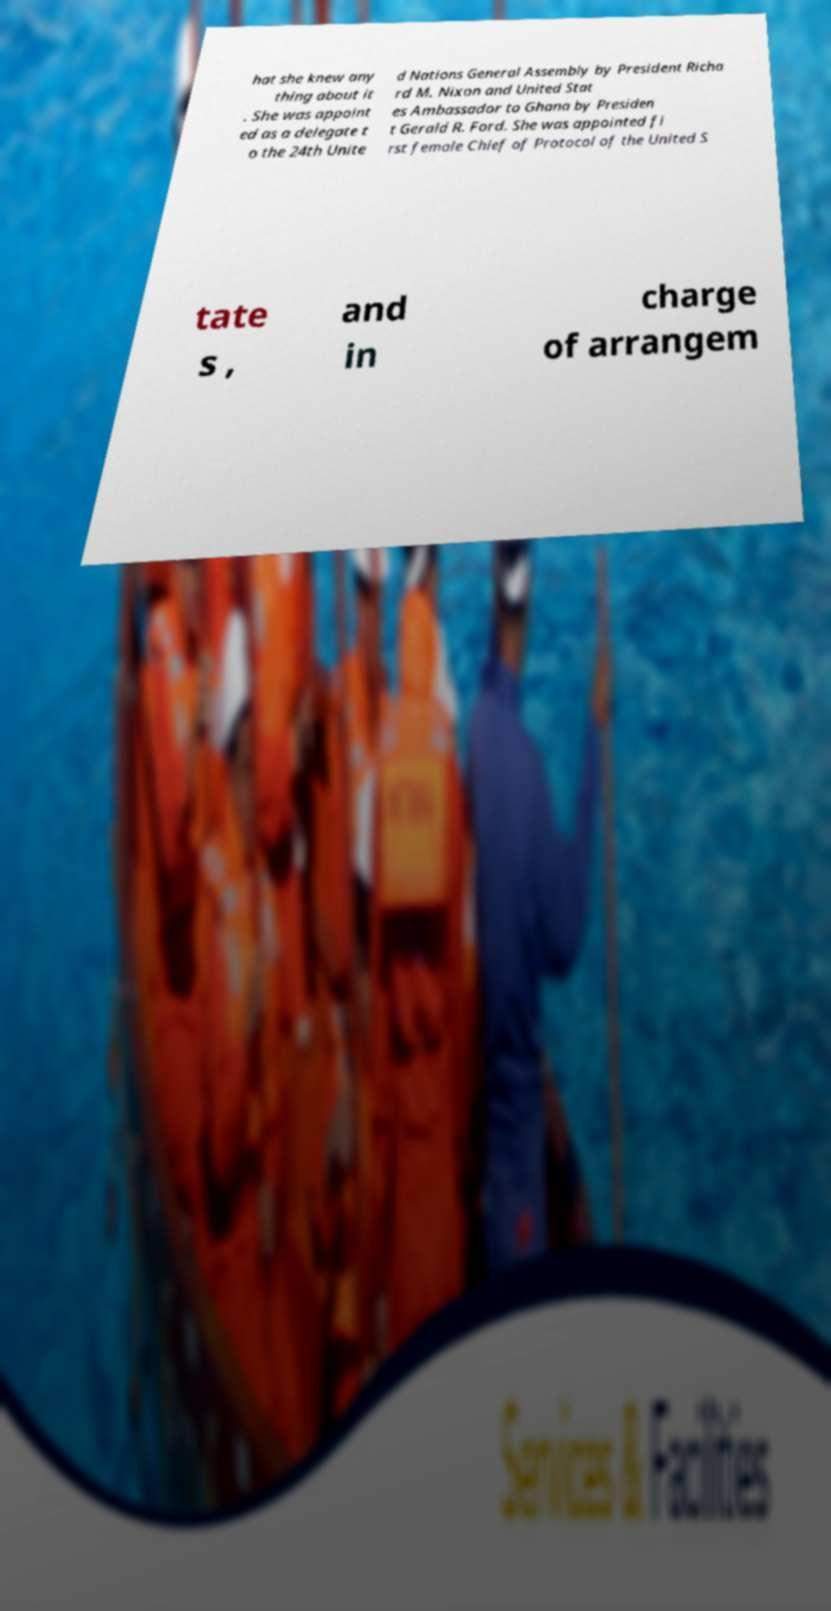I need the written content from this picture converted into text. Can you do that? hat she knew any thing about it . She was appoint ed as a delegate t o the 24th Unite d Nations General Assembly by President Richa rd M. Nixon and United Stat es Ambassador to Ghana by Presiden t Gerald R. Ford. She was appointed fi rst female Chief of Protocol of the United S tate s , and in charge of arrangem 